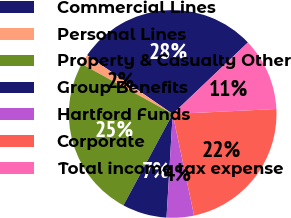<chart> <loc_0><loc_0><loc_500><loc_500><pie_chart><fcel>Commercial Lines<fcel>Personal Lines<fcel>Property & Casualty Other<fcel>Group Benefits<fcel>Hartford Funds<fcel>Corporate<fcel>Total income tax expense<nl><fcel>28.33%<fcel>1.57%<fcel>25.14%<fcel>6.92%<fcel>4.25%<fcel>22.46%<fcel>11.33%<nl></chart> 